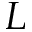<formula> <loc_0><loc_0><loc_500><loc_500>L</formula> 